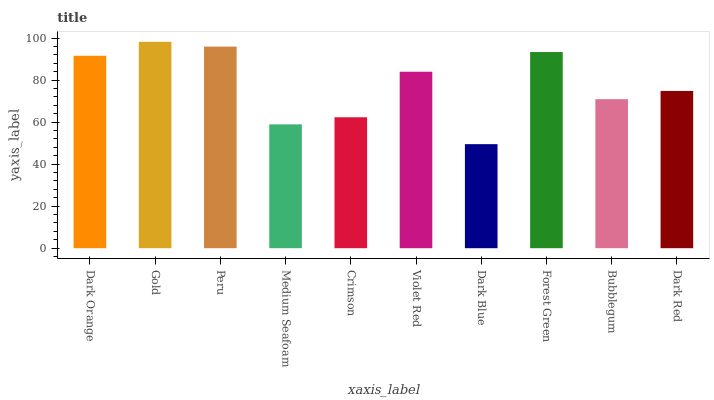Is Peru the minimum?
Answer yes or no. No. Is Peru the maximum?
Answer yes or no. No. Is Gold greater than Peru?
Answer yes or no. Yes. Is Peru less than Gold?
Answer yes or no. Yes. Is Peru greater than Gold?
Answer yes or no. No. Is Gold less than Peru?
Answer yes or no. No. Is Violet Red the high median?
Answer yes or no. Yes. Is Dark Red the low median?
Answer yes or no. Yes. Is Dark Blue the high median?
Answer yes or no. No. Is Medium Seafoam the low median?
Answer yes or no. No. 